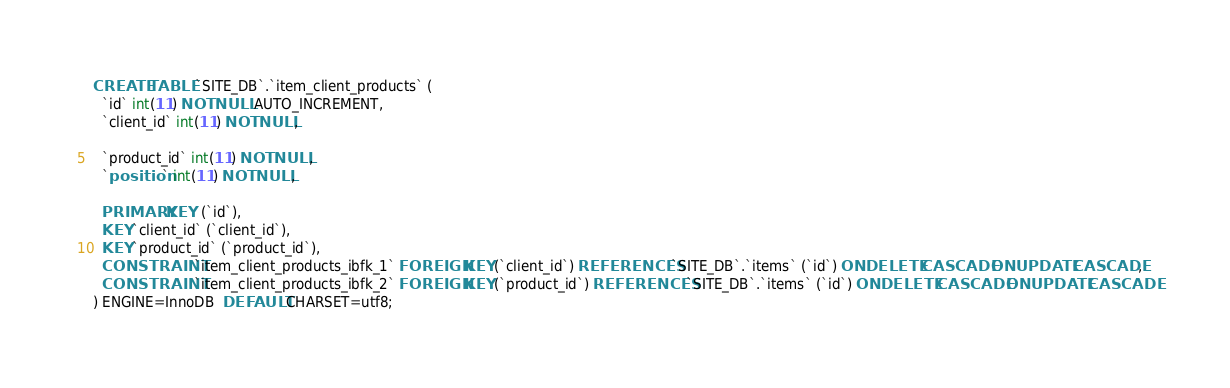<code> <loc_0><loc_0><loc_500><loc_500><_SQL_>CREATE TABLE `SITE_DB`.`item_client_products` (
  `id` int(11) NOT NULL AUTO_INCREMENT,
  `client_id` int(11) NOT NULL,

  `product_id` int(11) NOT NULL,
  `position` int(11) NOT NULL,

  PRIMARY KEY  (`id`),
  KEY `client_id` (`client_id`),
  KEY `product_id` (`product_id`),
  CONSTRAINT `item_client_products_ibfk_1` FOREIGN KEY (`client_id`) REFERENCES `SITE_DB`.`items` (`id`) ON DELETE CASCADE ON UPDATE CASCADE,
  CONSTRAINT `item_client_products_ibfk_2` FOREIGN KEY (`product_id`) REFERENCES `SITE_DB`.`items` (`id`) ON DELETE CASCADE ON UPDATE CASCADE
) ENGINE=InnoDB  DEFAULT CHARSET=utf8;
</code> 